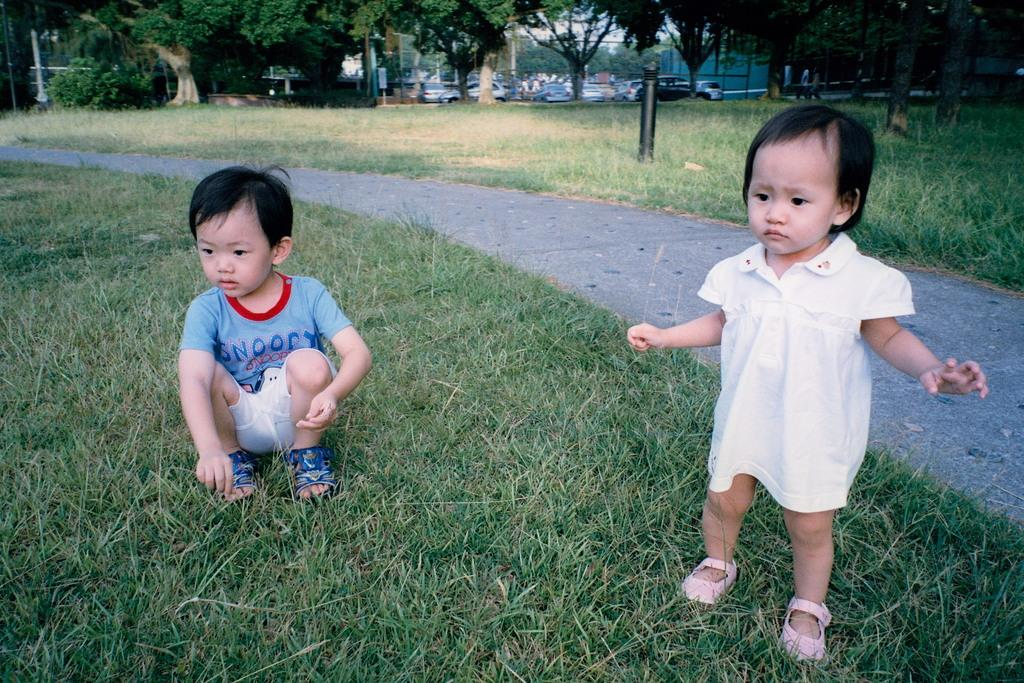<image>
Render a clear and concise summary of the photo. Two children are on the grass, including one who's shirt says "Snoopy" on the front. 